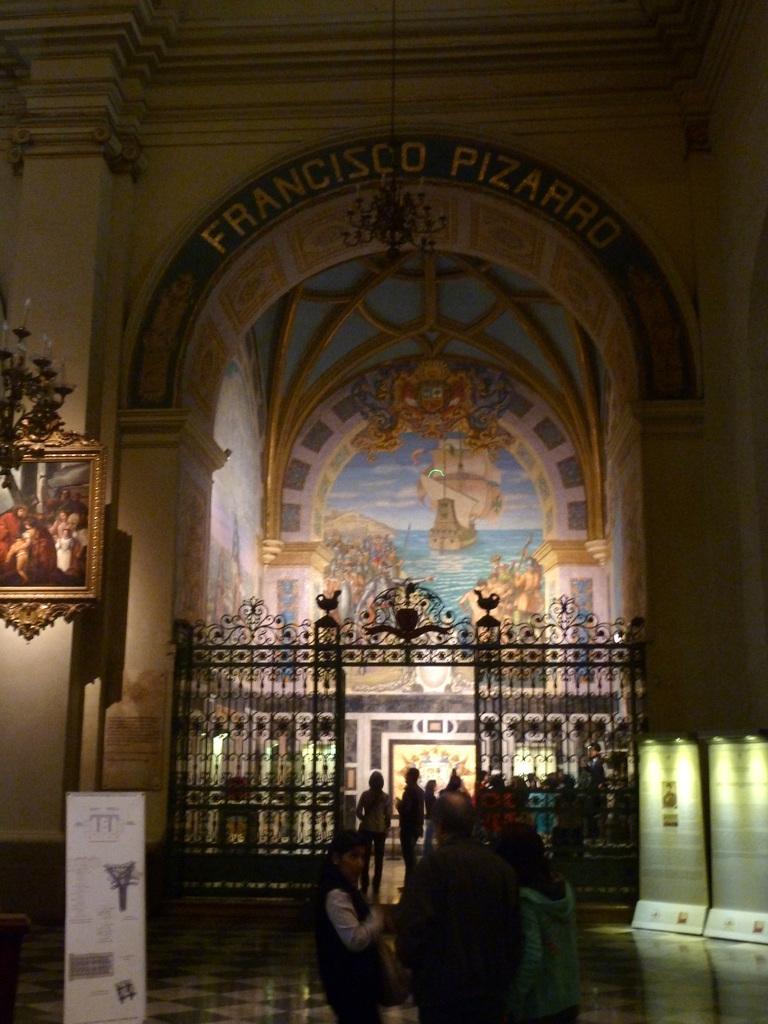Please provide a concise description of this image. At the bottom, we can see few people, grills, banners, poster, floor and wall. On the left side, we can see a photo frame and chandelier. Background we can see painting on the wall and some text. 